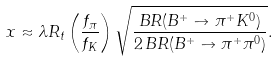Convert formula to latex. <formula><loc_0><loc_0><loc_500><loc_500>x \approx \lambda R _ { t } \left ( \frac { f _ { \pi } } { f _ { K } } \right ) \sqrt { \frac { B R ( B ^ { + } \to \pi ^ { + } K ^ { 0 } ) } { 2 \, B R ( B ^ { + } \to \pi ^ { + } \pi ^ { 0 } ) } } .</formula> 